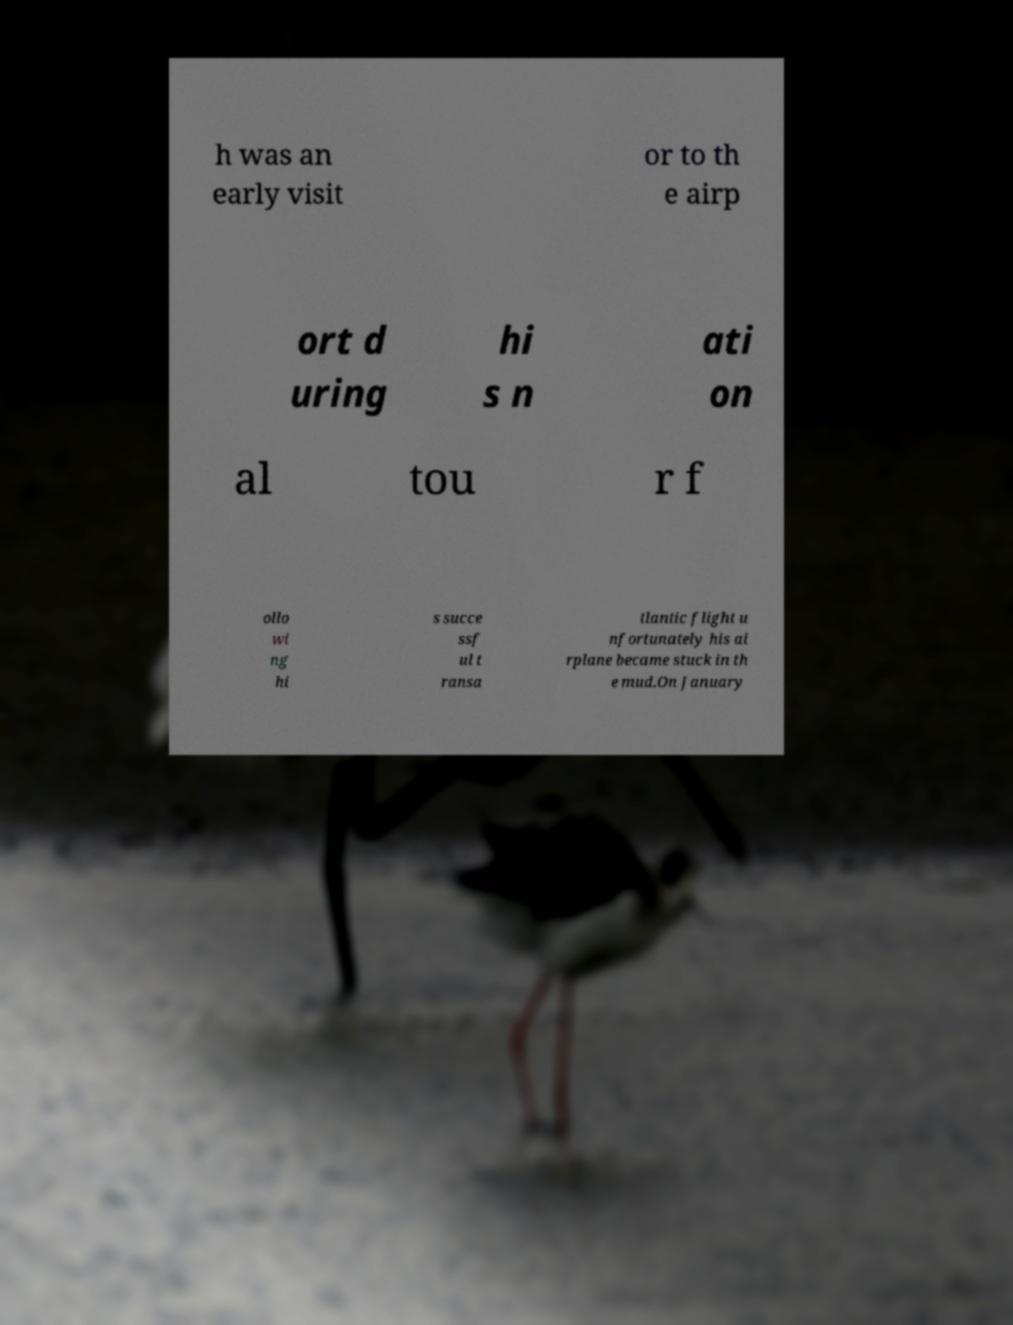What messages or text are displayed in this image? I need them in a readable, typed format. h was an early visit or to th e airp ort d uring hi s n ati on al tou r f ollo wi ng hi s succe ssf ul t ransa tlantic flight u nfortunately his ai rplane became stuck in th e mud.On January 